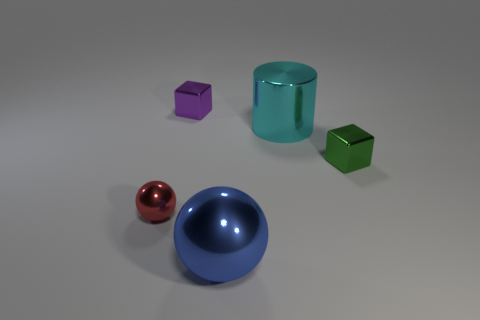Do the small shiny object that is to the right of the small purple block and the blue metal object have the same shape?
Provide a succinct answer. No. Are there fewer tiny metal objects to the left of the big cyan metallic thing than metallic objects that are behind the blue thing?
Keep it short and to the point. Yes. There is a block that is to the right of the cyan cylinder; what material is it?
Offer a very short reply. Metal. Are there any green metal things of the same size as the green block?
Offer a very short reply. No. There is a small purple object; is it the same shape as the green thing that is in front of the big cylinder?
Provide a succinct answer. Yes. There is a metal cube that is to the right of the blue metallic sphere; does it have the same size as the thing to the left of the tiny purple cube?
Your response must be concise. Yes. What number of other things are the same shape as the tiny red shiny thing?
Ensure brevity in your answer.  1. How many matte objects are red cubes or small red things?
Your answer should be compact. 0. There is a big object that is in front of the small red shiny sphere; are there any cylinders that are behind it?
Make the answer very short. Yes. How many objects are either objects that are on the right side of the big cyan cylinder or tiny metallic things that are on the right side of the large metallic cylinder?
Offer a terse response. 1. 